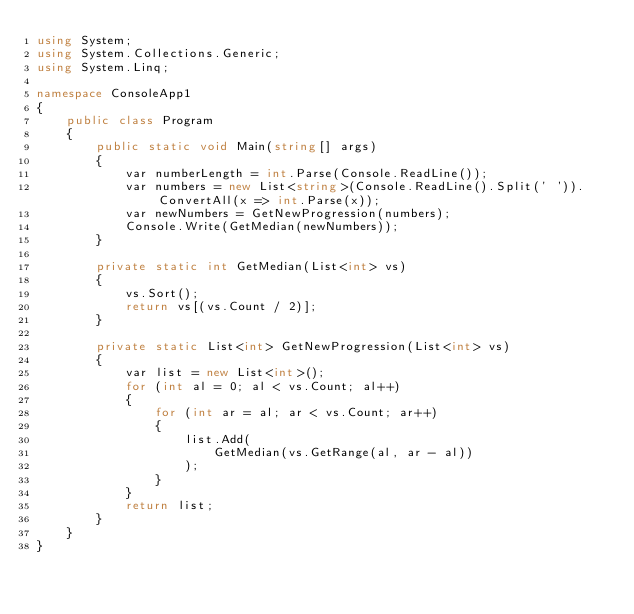<code> <loc_0><loc_0><loc_500><loc_500><_C#_>using System;
using System.Collections.Generic;
using System.Linq;

namespace ConsoleApp1
{
    public class Program
    {
        public static void Main(string[] args)
        {
            var numberLength = int.Parse(Console.ReadLine());
            var numbers = new List<string>(Console.ReadLine().Split(' ')).ConvertAll(x => int.Parse(x));
            var newNumbers = GetNewProgression(numbers);
            Console.Write(GetMedian(newNumbers));
        }

        private static int GetMedian(List<int> vs)
        {
            vs.Sort();
            return vs[(vs.Count / 2)];
        }

        private static List<int> GetNewProgression(List<int> vs)
        {
            var list = new List<int>();
            for (int al = 0; al < vs.Count; al++)
            {
                for (int ar = al; ar < vs.Count; ar++)
                {
                    list.Add(
                        GetMedian(vs.GetRange(al, ar - al))
                    );
                }
            }
            return list;
        }
    }
}
</code> 